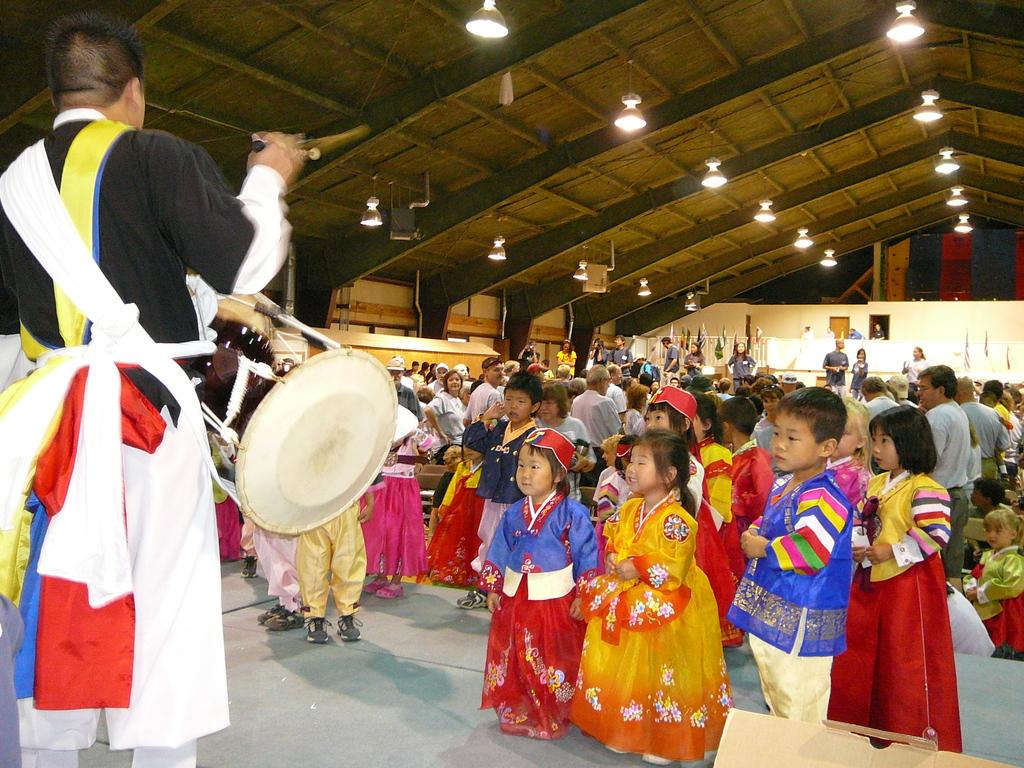How many children are in the image? There are children in the image, but the exact number is not specified. Where are the children positioned in relation to the other subjects in the image? The children are standing in front in the image. What is the man in the image doing? The man is standing and performing with drums in the image. What type of meat is being prepared in the field in the image? There is no meat or field present in the image; it features children standing in front and a man performing with drums. 